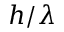<formula> <loc_0><loc_0><loc_500><loc_500>h / { \lambda }</formula> 